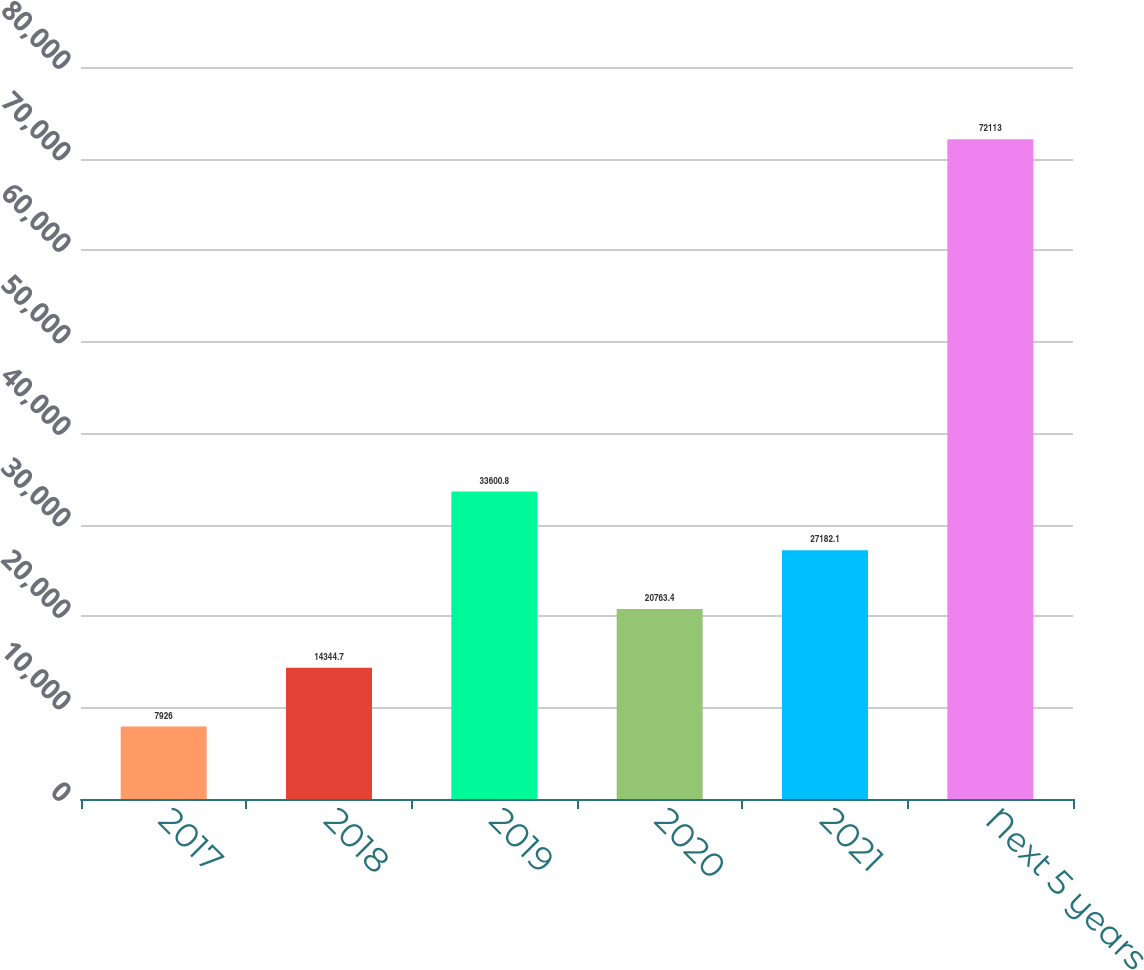Convert chart to OTSL. <chart><loc_0><loc_0><loc_500><loc_500><bar_chart><fcel>2017<fcel>2018<fcel>2019<fcel>2020<fcel>2021<fcel>Next 5 years<nl><fcel>7926<fcel>14344.7<fcel>33600.8<fcel>20763.4<fcel>27182.1<fcel>72113<nl></chart> 